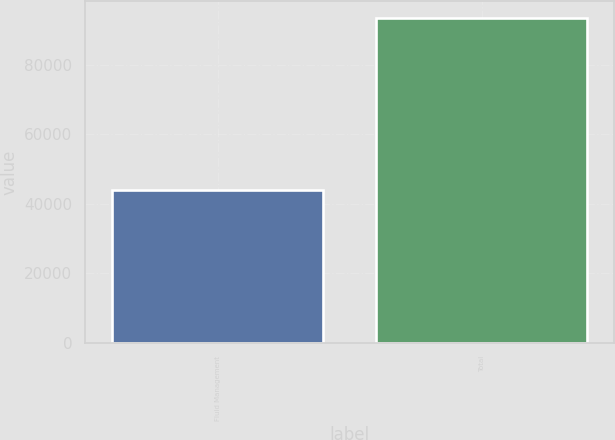<chart> <loc_0><loc_0><loc_500><loc_500><bar_chart><fcel>Fluid Management<fcel>Total<nl><fcel>43882<fcel>93689<nl></chart> 